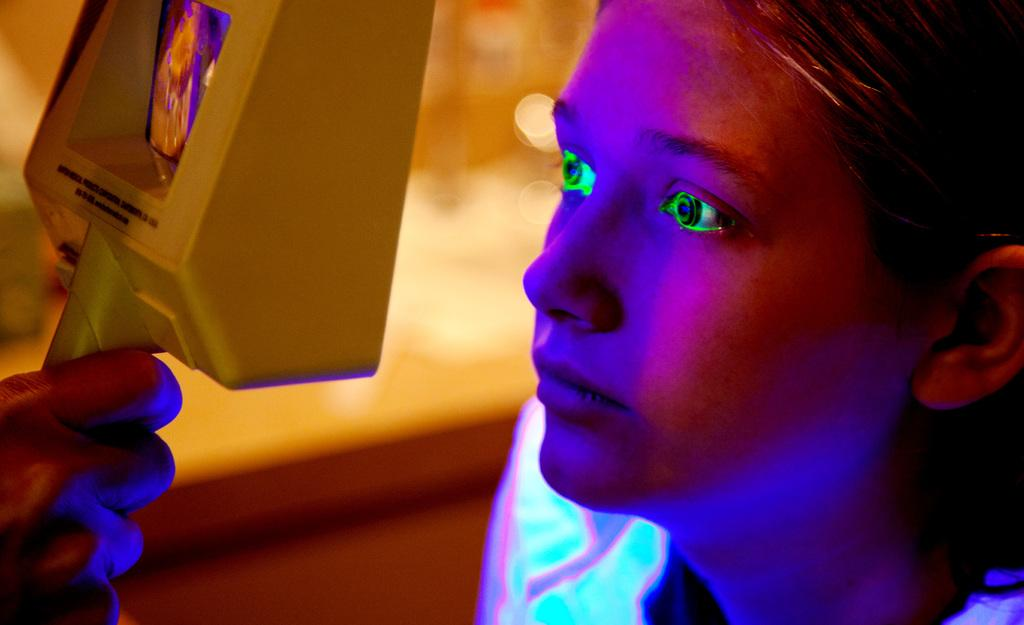What is the main subject of the image? There is a person's face in the image. What is the person doing with their hand in the image? The person's hand is holding an electronic device. Can you describe the background of the image? The background of the image is blurred. What type of horn is visible on the person's face in the image? There is no horn visible on the person's face in the image. Is the person wearing a mask in the image? There is no mention of a mask in the image, only the person's face and an electronic device are visible. What kind of beast can be seen in the background of the image? There is no beast present in the image; the background is blurred. 